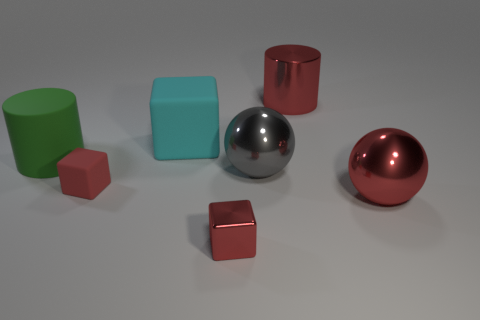What material is the tiny object that is the same color as the tiny metal block?
Your answer should be compact. Rubber. Do the gray thing and the red rubber block have the same size?
Your answer should be compact. No. There is a tiny red thing that is on the right side of the tiny rubber object; what material is it?
Provide a short and direct response. Metal. There is a big cyan object that is the same shape as the tiny red shiny object; what is it made of?
Make the answer very short. Rubber. Is there a thing that is to the right of the cylinder that is on the left side of the large red cylinder?
Offer a very short reply. Yes. Is the shape of the red rubber thing the same as the big cyan rubber thing?
Your answer should be very brief. Yes. The gray thing that is the same material as the large red sphere is what shape?
Provide a succinct answer. Sphere. There is a metal thing that is in front of the big red ball; is its size the same as the red object left of the big cyan block?
Your response must be concise. Yes. Is the number of small red metal cubes that are on the left side of the big gray metallic thing greater than the number of large red cylinders left of the small matte thing?
Your response must be concise. Yes. What number of other objects are there of the same color as the metallic cube?
Your response must be concise. 3. 